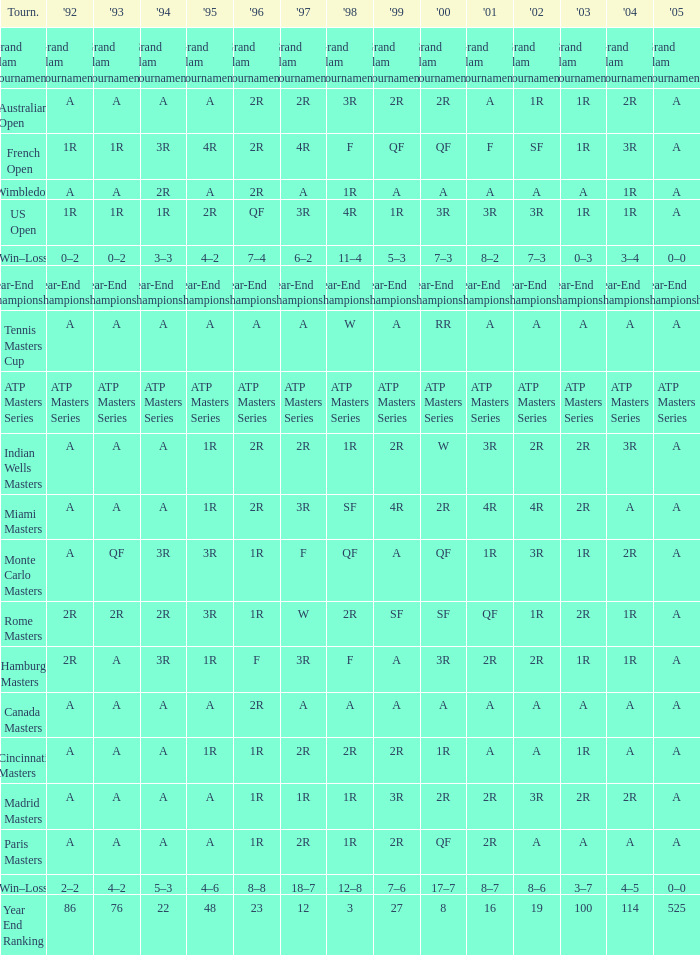Give me the full table as a dictionary. {'header': ['Tourn.', "'92", "'93", "'94", "'95", "'96", "'97", "'98", "'99", "'00", "'01", "'02", "'03", "'04", "'05"], 'rows': [['Grand Slam Tournaments', 'Grand Slam Tournaments', 'Grand Slam Tournaments', 'Grand Slam Tournaments', 'Grand Slam Tournaments', 'Grand Slam Tournaments', 'Grand Slam Tournaments', 'Grand Slam Tournaments', 'Grand Slam Tournaments', 'Grand Slam Tournaments', 'Grand Slam Tournaments', 'Grand Slam Tournaments', 'Grand Slam Tournaments', 'Grand Slam Tournaments', 'Grand Slam Tournaments'], ['Australian Open', 'A', 'A', 'A', 'A', '2R', '2R', '3R', '2R', '2R', 'A', '1R', '1R', '2R', 'A'], ['French Open', '1R', '1R', '3R', '4R', '2R', '4R', 'F', 'QF', 'QF', 'F', 'SF', '1R', '3R', 'A'], ['Wimbledon', 'A', 'A', '2R', 'A', '2R', 'A', '1R', 'A', 'A', 'A', 'A', 'A', '1R', 'A'], ['US Open', '1R', '1R', '1R', '2R', 'QF', '3R', '4R', '1R', '3R', '3R', '3R', '1R', '1R', 'A'], ['Win–Loss', '0–2', '0–2', '3–3', '4–2', '7–4', '6–2', '11–4', '5–3', '7–3', '8–2', '7–3', '0–3', '3–4', '0–0'], ['Year-End Championship', 'Year-End Championship', 'Year-End Championship', 'Year-End Championship', 'Year-End Championship', 'Year-End Championship', 'Year-End Championship', 'Year-End Championship', 'Year-End Championship', 'Year-End Championship', 'Year-End Championship', 'Year-End Championship', 'Year-End Championship', 'Year-End Championship', 'Year-End Championship'], ['Tennis Masters Cup', 'A', 'A', 'A', 'A', 'A', 'A', 'W', 'A', 'RR', 'A', 'A', 'A', 'A', 'A'], ['ATP Masters Series', 'ATP Masters Series', 'ATP Masters Series', 'ATP Masters Series', 'ATP Masters Series', 'ATP Masters Series', 'ATP Masters Series', 'ATP Masters Series', 'ATP Masters Series', 'ATP Masters Series', 'ATP Masters Series', 'ATP Masters Series', 'ATP Masters Series', 'ATP Masters Series', 'ATP Masters Series'], ['Indian Wells Masters', 'A', 'A', 'A', '1R', '2R', '2R', '1R', '2R', 'W', '3R', '2R', '2R', '3R', 'A'], ['Miami Masters', 'A', 'A', 'A', '1R', '2R', '3R', 'SF', '4R', '2R', '4R', '4R', '2R', 'A', 'A'], ['Monte Carlo Masters', 'A', 'QF', '3R', '3R', '1R', 'F', 'QF', 'A', 'QF', '1R', '3R', '1R', '2R', 'A'], ['Rome Masters', '2R', '2R', '2R', '3R', '1R', 'W', '2R', 'SF', 'SF', 'QF', '1R', '2R', '1R', 'A'], ['Hamburg Masters', '2R', 'A', '3R', '1R', 'F', '3R', 'F', 'A', '3R', '2R', '2R', '1R', '1R', 'A'], ['Canada Masters', 'A', 'A', 'A', 'A', '2R', 'A', 'A', 'A', 'A', 'A', 'A', 'A', 'A', 'A'], ['Cincinnati Masters', 'A', 'A', 'A', '1R', '1R', '2R', '2R', '2R', '1R', 'A', 'A', '1R', 'A', 'A'], ['Madrid Masters', 'A', 'A', 'A', 'A', '1R', '1R', '1R', '3R', '2R', '2R', '3R', '2R', '2R', 'A'], ['Paris Masters', 'A', 'A', 'A', 'A', '1R', '2R', '1R', '2R', 'QF', '2R', 'A', 'A', 'A', 'A'], ['Win–Loss', '2–2', '4–2', '5–3', '4–6', '8–8', '18–7', '12–8', '7–6', '17–7', '8–7', '8–6', '3–7', '4–5', '0–0'], ['Year End Ranking', '86', '76', '22', '48', '23', '12', '3', '27', '8', '16', '19', '100', '114', '525']]} What is 1992, when 1999 is "Year-End Championship"? Year-End Championship. 